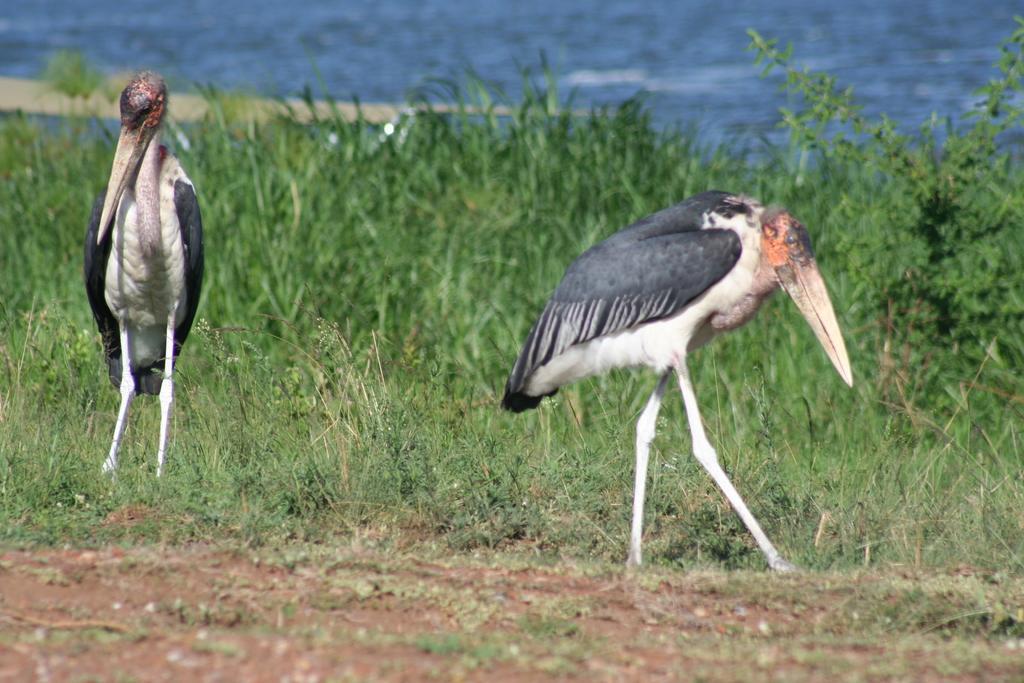Can you describe this image briefly? In the foreground of the picture we can see grass, soil and cranes. In the middle we can see plants and grass. At the top there is a water body. 